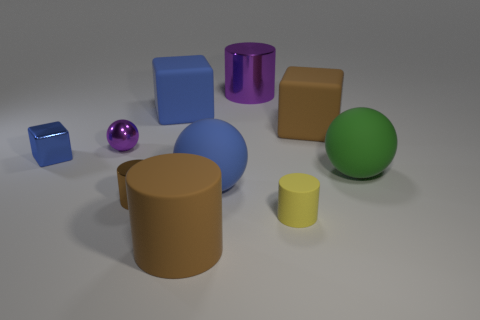Subtract all balls. How many objects are left? 7 Subtract 0 purple cubes. How many objects are left? 10 Subtract all small blue things. Subtract all small spheres. How many objects are left? 8 Add 1 blue cubes. How many blue cubes are left? 3 Add 4 big yellow matte things. How many big yellow matte things exist? 4 